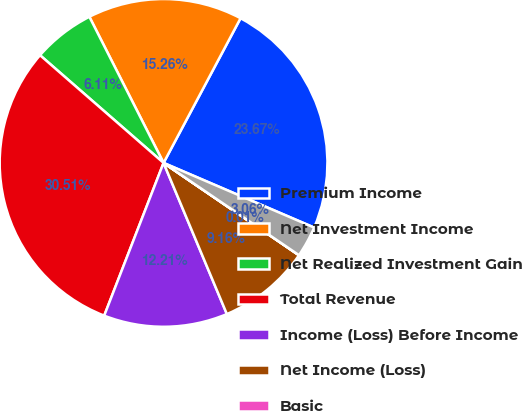<chart> <loc_0><loc_0><loc_500><loc_500><pie_chart><fcel>Premium Income<fcel>Net Investment Income<fcel>Net Realized Investment Gain<fcel>Total Revenue<fcel>Income (Loss) Before Income<fcel>Net Income (Loss)<fcel>Basic<fcel>Assuming Dilution<nl><fcel>23.67%<fcel>15.26%<fcel>6.11%<fcel>30.51%<fcel>12.21%<fcel>9.16%<fcel>0.01%<fcel>3.06%<nl></chart> 